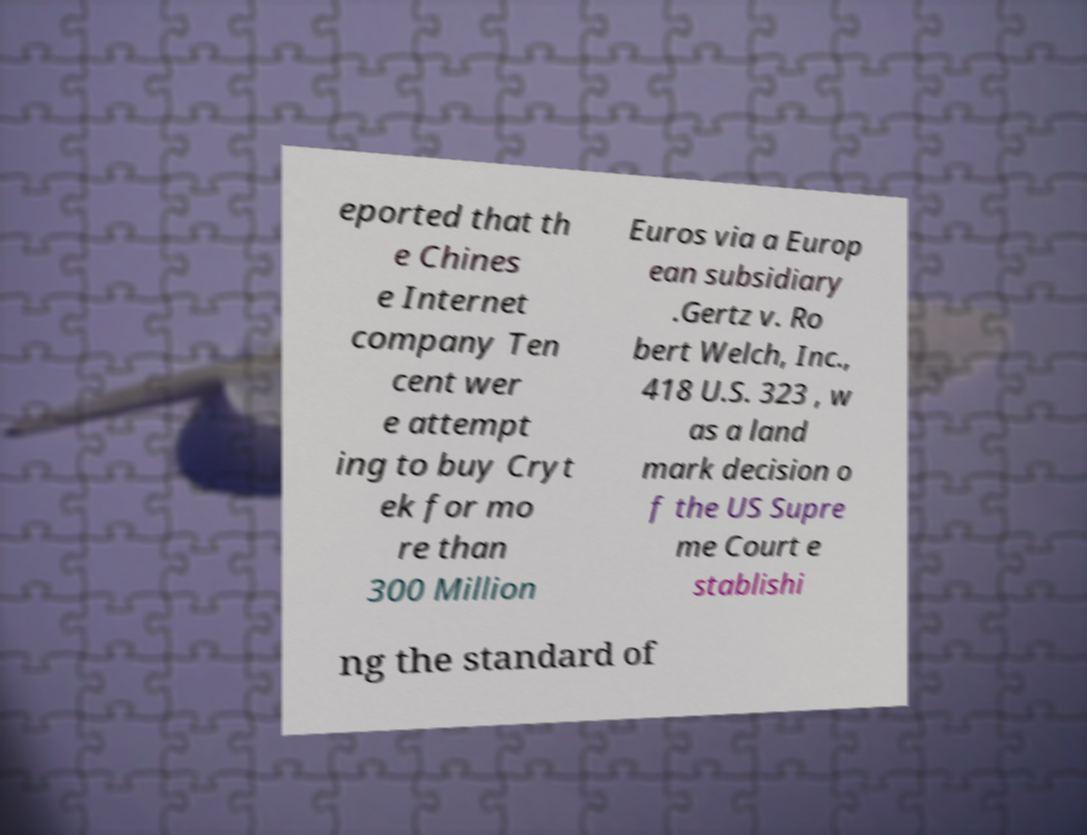Please read and relay the text visible in this image. What does it say? eported that th e Chines e Internet company Ten cent wer e attempt ing to buy Cryt ek for mo re than 300 Million Euros via a Europ ean subsidiary .Gertz v. Ro bert Welch, Inc., 418 U.S. 323 , w as a land mark decision o f the US Supre me Court e stablishi ng the standard of 